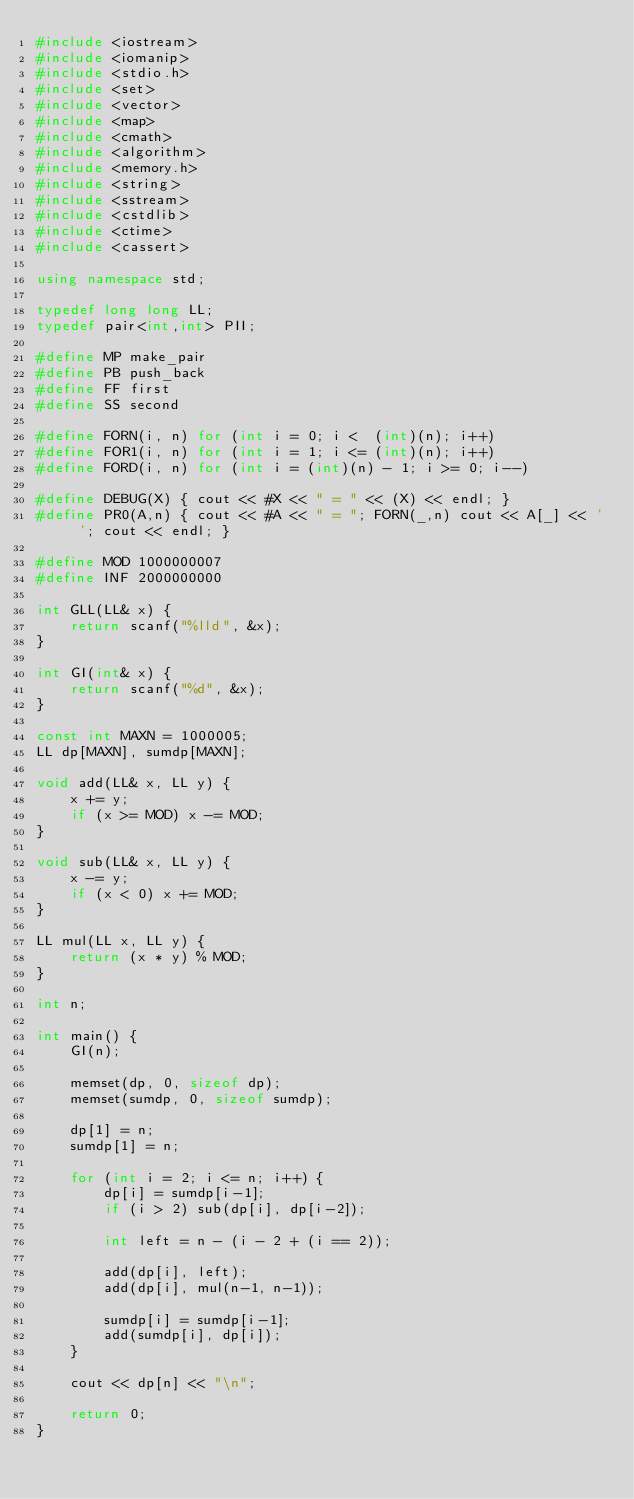<code> <loc_0><loc_0><loc_500><loc_500><_C++_>#include <iostream>
#include <iomanip>
#include <stdio.h>
#include <set>
#include <vector>
#include <map>
#include <cmath>
#include <algorithm>
#include <memory.h>
#include <string>
#include <sstream>
#include <cstdlib>
#include <ctime>
#include <cassert>

using namespace std;

typedef long long LL;
typedef pair<int,int> PII;

#define MP make_pair
#define PB push_back
#define FF first
#define SS second

#define FORN(i, n) for (int i = 0; i <  (int)(n); i++)
#define FOR1(i, n) for (int i = 1; i <= (int)(n); i++)
#define FORD(i, n) for (int i = (int)(n) - 1; i >= 0; i--)

#define DEBUG(X) { cout << #X << " = " << (X) << endl; }
#define PR0(A,n) { cout << #A << " = "; FORN(_,n) cout << A[_] << ' '; cout << endl; }

#define MOD 1000000007
#define INF 2000000000

int GLL(LL& x) {
    return scanf("%lld", &x);
}

int GI(int& x) {
    return scanf("%d", &x);
}

const int MAXN = 1000005;
LL dp[MAXN], sumdp[MAXN];

void add(LL& x, LL y) {
    x += y;
    if (x >= MOD) x -= MOD;
}

void sub(LL& x, LL y) {
    x -= y;
    if (x < 0) x += MOD;
}

LL mul(LL x, LL y) {
    return (x * y) % MOD;
}

int n;

int main() {
    GI(n);

    memset(dp, 0, sizeof dp);
    memset(sumdp, 0, sizeof sumdp);

    dp[1] = n;
    sumdp[1] = n;

    for (int i = 2; i <= n; i++) {
        dp[i] = sumdp[i-1];
        if (i > 2) sub(dp[i], dp[i-2]);

        int left = n - (i - 2 + (i == 2));

        add(dp[i], left);
        add(dp[i], mul(n-1, n-1));

        sumdp[i] = sumdp[i-1];
        add(sumdp[i], dp[i]);
    }

    cout << dp[n] << "\n";

    return 0;
}</code> 